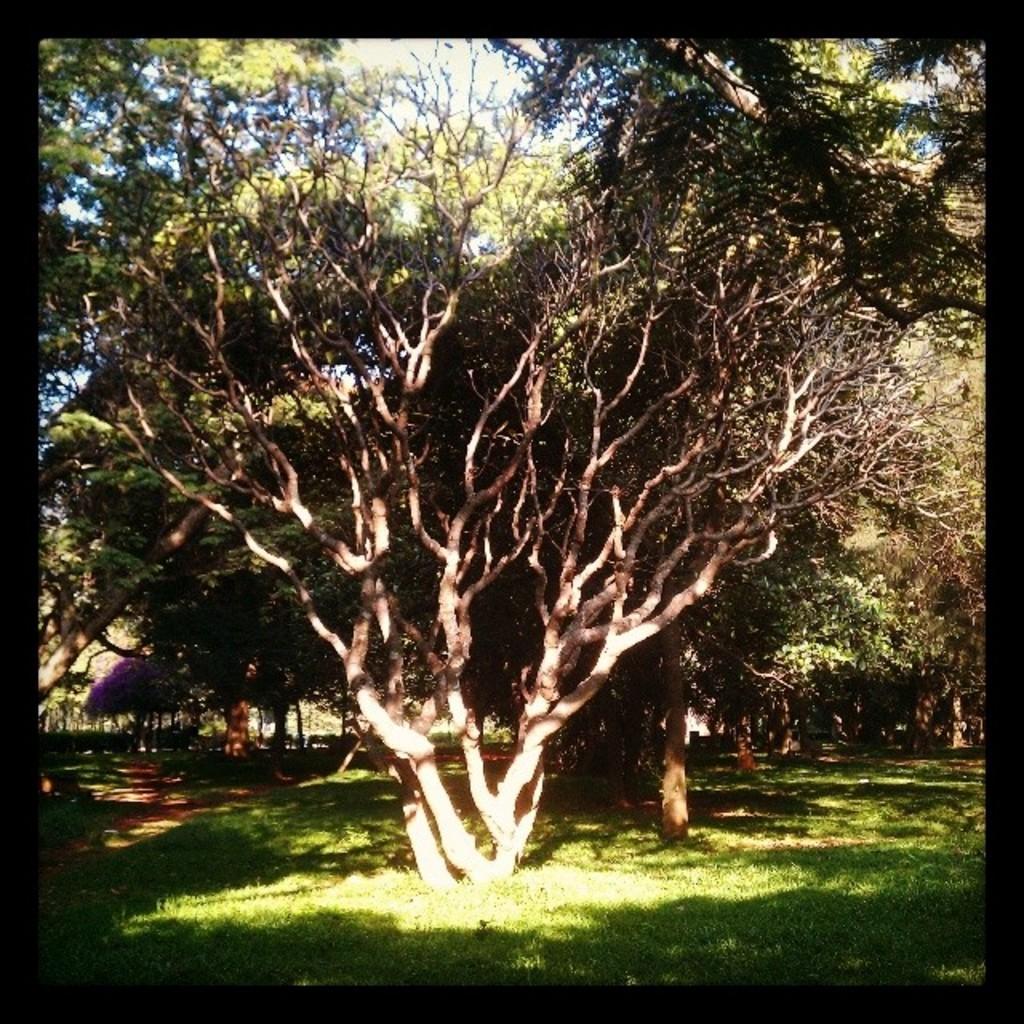Please provide a concise description of this image. In this picture there are trees. At the top there is sky. At the bottom there is grass. 